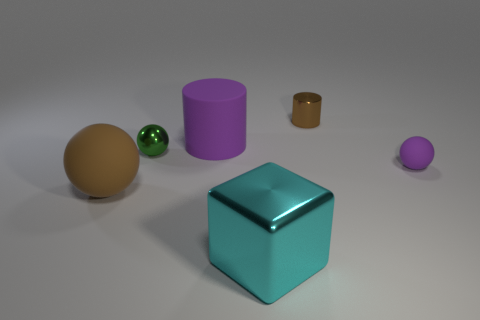There is a large sphere that is the same color as the tiny metallic cylinder; what is it made of?
Your answer should be compact. Rubber. How many things are either rubber spheres to the right of the small green object or small gray shiny balls?
Offer a terse response. 1. Do the matte object behind the shiny ball and the cyan cube have the same size?
Make the answer very short. Yes. Is the number of purple rubber cylinders that are in front of the purple rubber cylinder less than the number of big brown rubber objects?
Offer a terse response. Yes. What is the material of the cyan object that is the same size as the purple rubber cylinder?
Ensure brevity in your answer.  Metal. How many big things are either green metal objects or purple objects?
Provide a short and direct response. 1. How many objects are things behind the large metallic block or metallic things that are behind the large metal thing?
Your answer should be very brief. 5. Are there fewer rubber spheres than brown spheres?
Give a very brief answer. No. What shape is the brown object that is the same size as the metallic sphere?
Keep it short and to the point. Cylinder. What number of other objects are there of the same color as the tiny metal sphere?
Offer a terse response. 0. 